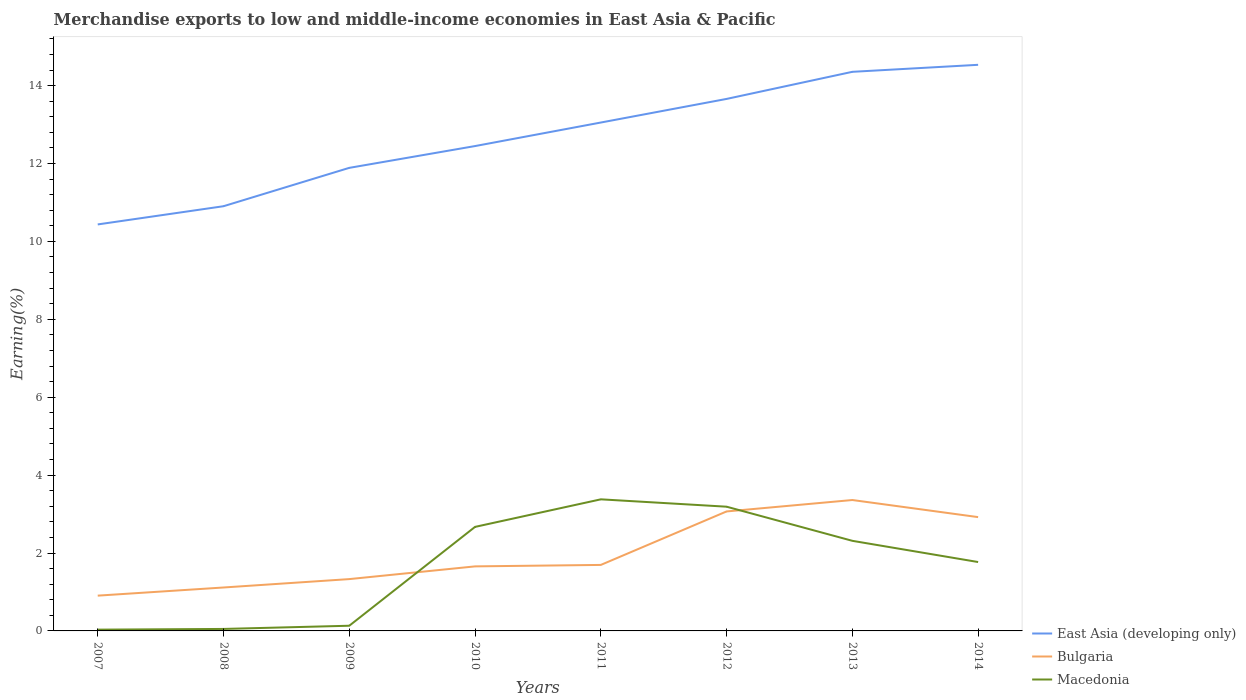Is the number of lines equal to the number of legend labels?
Ensure brevity in your answer.  Yes. Across all years, what is the maximum percentage of amount earned from merchandise exports in East Asia (developing only)?
Your answer should be very brief. 10.44. What is the total percentage of amount earned from merchandise exports in Bulgaria in the graph?
Provide a succinct answer. -0.29. What is the difference between the highest and the second highest percentage of amount earned from merchandise exports in Bulgaria?
Keep it short and to the point. 2.45. What is the difference between the highest and the lowest percentage of amount earned from merchandise exports in Bulgaria?
Your answer should be very brief. 3. Is the percentage of amount earned from merchandise exports in Bulgaria strictly greater than the percentage of amount earned from merchandise exports in East Asia (developing only) over the years?
Ensure brevity in your answer.  Yes. How many lines are there?
Provide a short and direct response. 3. How many years are there in the graph?
Provide a succinct answer. 8. Does the graph contain any zero values?
Provide a short and direct response. No. Where does the legend appear in the graph?
Offer a terse response. Bottom right. How many legend labels are there?
Make the answer very short. 3. What is the title of the graph?
Offer a terse response. Merchandise exports to low and middle-income economies in East Asia & Pacific. Does "Tajikistan" appear as one of the legend labels in the graph?
Offer a very short reply. No. What is the label or title of the Y-axis?
Make the answer very short. Earning(%). What is the Earning(%) of East Asia (developing only) in 2007?
Keep it short and to the point. 10.44. What is the Earning(%) in Bulgaria in 2007?
Make the answer very short. 0.91. What is the Earning(%) in Macedonia in 2007?
Give a very brief answer. 0.03. What is the Earning(%) of East Asia (developing only) in 2008?
Your response must be concise. 10.9. What is the Earning(%) in Bulgaria in 2008?
Offer a very short reply. 1.11. What is the Earning(%) of Macedonia in 2008?
Keep it short and to the point. 0.05. What is the Earning(%) of East Asia (developing only) in 2009?
Offer a very short reply. 11.89. What is the Earning(%) of Bulgaria in 2009?
Offer a very short reply. 1.33. What is the Earning(%) in Macedonia in 2009?
Your answer should be compact. 0.13. What is the Earning(%) of East Asia (developing only) in 2010?
Provide a short and direct response. 12.45. What is the Earning(%) in Bulgaria in 2010?
Provide a succinct answer. 1.66. What is the Earning(%) in Macedonia in 2010?
Give a very brief answer. 2.67. What is the Earning(%) in East Asia (developing only) in 2011?
Your answer should be very brief. 13.05. What is the Earning(%) in Bulgaria in 2011?
Make the answer very short. 1.69. What is the Earning(%) in Macedonia in 2011?
Ensure brevity in your answer.  3.38. What is the Earning(%) of East Asia (developing only) in 2012?
Offer a terse response. 13.66. What is the Earning(%) of Bulgaria in 2012?
Provide a short and direct response. 3.07. What is the Earning(%) of Macedonia in 2012?
Offer a terse response. 3.19. What is the Earning(%) of East Asia (developing only) in 2013?
Offer a very short reply. 14.35. What is the Earning(%) in Bulgaria in 2013?
Offer a terse response. 3.36. What is the Earning(%) of Macedonia in 2013?
Offer a terse response. 2.31. What is the Earning(%) of East Asia (developing only) in 2014?
Your answer should be compact. 14.53. What is the Earning(%) in Bulgaria in 2014?
Provide a succinct answer. 2.92. What is the Earning(%) in Macedonia in 2014?
Your response must be concise. 1.77. Across all years, what is the maximum Earning(%) in East Asia (developing only)?
Ensure brevity in your answer.  14.53. Across all years, what is the maximum Earning(%) of Bulgaria?
Your answer should be very brief. 3.36. Across all years, what is the maximum Earning(%) in Macedonia?
Offer a very short reply. 3.38. Across all years, what is the minimum Earning(%) in East Asia (developing only)?
Your answer should be very brief. 10.44. Across all years, what is the minimum Earning(%) in Bulgaria?
Give a very brief answer. 0.91. Across all years, what is the minimum Earning(%) of Macedonia?
Your response must be concise. 0.03. What is the total Earning(%) of East Asia (developing only) in the graph?
Your response must be concise. 101.27. What is the total Earning(%) in Bulgaria in the graph?
Your answer should be very brief. 16.05. What is the total Earning(%) in Macedonia in the graph?
Provide a short and direct response. 13.54. What is the difference between the Earning(%) in East Asia (developing only) in 2007 and that in 2008?
Provide a short and direct response. -0.47. What is the difference between the Earning(%) in Bulgaria in 2007 and that in 2008?
Give a very brief answer. -0.21. What is the difference between the Earning(%) of Macedonia in 2007 and that in 2008?
Offer a terse response. -0.02. What is the difference between the Earning(%) in East Asia (developing only) in 2007 and that in 2009?
Offer a very short reply. -1.45. What is the difference between the Earning(%) in Bulgaria in 2007 and that in 2009?
Your response must be concise. -0.42. What is the difference between the Earning(%) in Macedonia in 2007 and that in 2009?
Give a very brief answer. -0.1. What is the difference between the Earning(%) in East Asia (developing only) in 2007 and that in 2010?
Your response must be concise. -2.01. What is the difference between the Earning(%) of Bulgaria in 2007 and that in 2010?
Give a very brief answer. -0.75. What is the difference between the Earning(%) of Macedonia in 2007 and that in 2010?
Provide a succinct answer. -2.64. What is the difference between the Earning(%) in East Asia (developing only) in 2007 and that in 2011?
Your answer should be very brief. -2.62. What is the difference between the Earning(%) of Bulgaria in 2007 and that in 2011?
Ensure brevity in your answer.  -0.79. What is the difference between the Earning(%) of Macedonia in 2007 and that in 2011?
Your answer should be compact. -3.35. What is the difference between the Earning(%) in East Asia (developing only) in 2007 and that in 2012?
Provide a succinct answer. -3.22. What is the difference between the Earning(%) of Bulgaria in 2007 and that in 2012?
Make the answer very short. -2.16. What is the difference between the Earning(%) in Macedonia in 2007 and that in 2012?
Make the answer very short. -3.16. What is the difference between the Earning(%) in East Asia (developing only) in 2007 and that in 2013?
Make the answer very short. -3.92. What is the difference between the Earning(%) in Bulgaria in 2007 and that in 2013?
Your response must be concise. -2.45. What is the difference between the Earning(%) in Macedonia in 2007 and that in 2013?
Your answer should be compact. -2.28. What is the difference between the Earning(%) in East Asia (developing only) in 2007 and that in 2014?
Give a very brief answer. -4.1. What is the difference between the Earning(%) in Bulgaria in 2007 and that in 2014?
Ensure brevity in your answer.  -2.02. What is the difference between the Earning(%) of Macedonia in 2007 and that in 2014?
Give a very brief answer. -1.74. What is the difference between the Earning(%) of East Asia (developing only) in 2008 and that in 2009?
Give a very brief answer. -0.98. What is the difference between the Earning(%) in Bulgaria in 2008 and that in 2009?
Your answer should be very brief. -0.22. What is the difference between the Earning(%) in Macedonia in 2008 and that in 2009?
Keep it short and to the point. -0.08. What is the difference between the Earning(%) of East Asia (developing only) in 2008 and that in 2010?
Your answer should be very brief. -1.54. What is the difference between the Earning(%) of Bulgaria in 2008 and that in 2010?
Provide a short and direct response. -0.54. What is the difference between the Earning(%) in Macedonia in 2008 and that in 2010?
Ensure brevity in your answer.  -2.62. What is the difference between the Earning(%) of East Asia (developing only) in 2008 and that in 2011?
Provide a succinct answer. -2.15. What is the difference between the Earning(%) of Bulgaria in 2008 and that in 2011?
Your answer should be compact. -0.58. What is the difference between the Earning(%) of Macedonia in 2008 and that in 2011?
Offer a very short reply. -3.33. What is the difference between the Earning(%) in East Asia (developing only) in 2008 and that in 2012?
Give a very brief answer. -2.75. What is the difference between the Earning(%) of Bulgaria in 2008 and that in 2012?
Your answer should be very brief. -1.95. What is the difference between the Earning(%) of Macedonia in 2008 and that in 2012?
Provide a short and direct response. -3.14. What is the difference between the Earning(%) of East Asia (developing only) in 2008 and that in 2013?
Ensure brevity in your answer.  -3.45. What is the difference between the Earning(%) of Bulgaria in 2008 and that in 2013?
Ensure brevity in your answer.  -2.25. What is the difference between the Earning(%) in Macedonia in 2008 and that in 2013?
Offer a very short reply. -2.26. What is the difference between the Earning(%) of East Asia (developing only) in 2008 and that in 2014?
Your answer should be very brief. -3.63. What is the difference between the Earning(%) in Bulgaria in 2008 and that in 2014?
Make the answer very short. -1.81. What is the difference between the Earning(%) in Macedonia in 2008 and that in 2014?
Ensure brevity in your answer.  -1.72. What is the difference between the Earning(%) in East Asia (developing only) in 2009 and that in 2010?
Your answer should be compact. -0.56. What is the difference between the Earning(%) of Bulgaria in 2009 and that in 2010?
Ensure brevity in your answer.  -0.33. What is the difference between the Earning(%) in Macedonia in 2009 and that in 2010?
Your answer should be compact. -2.54. What is the difference between the Earning(%) of East Asia (developing only) in 2009 and that in 2011?
Provide a short and direct response. -1.16. What is the difference between the Earning(%) in Bulgaria in 2009 and that in 2011?
Keep it short and to the point. -0.36. What is the difference between the Earning(%) of Macedonia in 2009 and that in 2011?
Offer a terse response. -3.25. What is the difference between the Earning(%) in East Asia (developing only) in 2009 and that in 2012?
Keep it short and to the point. -1.77. What is the difference between the Earning(%) of Bulgaria in 2009 and that in 2012?
Keep it short and to the point. -1.74. What is the difference between the Earning(%) in Macedonia in 2009 and that in 2012?
Your response must be concise. -3.06. What is the difference between the Earning(%) in East Asia (developing only) in 2009 and that in 2013?
Make the answer very short. -2.47. What is the difference between the Earning(%) of Bulgaria in 2009 and that in 2013?
Provide a succinct answer. -2.03. What is the difference between the Earning(%) in Macedonia in 2009 and that in 2013?
Ensure brevity in your answer.  -2.18. What is the difference between the Earning(%) in East Asia (developing only) in 2009 and that in 2014?
Provide a short and direct response. -2.65. What is the difference between the Earning(%) of Bulgaria in 2009 and that in 2014?
Give a very brief answer. -1.59. What is the difference between the Earning(%) in Macedonia in 2009 and that in 2014?
Offer a very short reply. -1.64. What is the difference between the Earning(%) in East Asia (developing only) in 2010 and that in 2011?
Provide a succinct answer. -0.6. What is the difference between the Earning(%) of Bulgaria in 2010 and that in 2011?
Keep it short and to the point. -0.04. What is the difference between the Earning(%) of Macedonia in 2010 and that in 2011?
Make the answer very short. -0.71. What is the difference between the Earning(%) of East Asia (developing only) in 2010 and that in 2012?
Keep it short and to the point. -1.21. What is the difference between the Earning(%) in Bulgaria in 2010 and that in 2012?
Your response must be concise. -1.41. What is the difference between the Earning(%) in Macedonia in 2010 and that in 2012?
Ensure brevity in your answer.  -0.52. What is the difference between the Earning(%) in East Asia (developing only) in 2010 and that in 2013?
Your answer should be very brief. -1.91. What is the difference between the Earning(%) in Bulgaria in 2010 and that in 2013?
Provide a succinct answer. -1.7. What is the difference between the Earning(%) of Macedonia in 2010 and that in 2013?
Provide a short and direct response. 0.36. What is the difference between the Earning(%) in East Asia (developing only) in 2010 and that in 2014?
Offer a terse response. -2.09. What is the difference between the Earning(%) of Bulgaria in 2010 and that in 2014?
Your answer should be very brief. -1.26. What is the difference between the Earning(%) of Macedonia in 2010 and that in 2014?
Make the answer very short. 0.9. What is the difference between the Earning(%) of East Asia (developing only) in 2011 and that in 2012?
Make the answer very short. -0.61. What is the difference between the Earning(%) of Bulgaria in 2011 and that in 2012?
Your answer should be compact. -1.37. What is the difference between the Earning(%) of Macedonia in 2011 and that in 2012?
Give a very brief answer. 0.19. What is the difference between the Earning(%) in East Asia (developing only) in 2011 and that in 2013?
Offer a very short reply. -1.3. What is the difference between the Earning(%) of Bulgaria in 2011 and that in 2013?
Give a very brief answer. -1.67. What is the difference between the Earning(%) of Macedonia in 2011 and that in 2013?
Keep it short and to the point. 1.07. What is the difference between the Earning(%) in East Asia (developing only) in 2011 and that in 2014?
Make the answer very short. -1.48. What is the difference between the Earning(%) of Bulgaria in 2011 and that in 2014?
Provide a succinct answer. -1.23. What is the difference between the Earning(%) of Macedonia in 2011 and that in 2014?
Ensure brevity in your answer.  1.61. What is the difference between the Earning(%) of East Asia (developing only) in 2012 and that in 2013?
Give a very brief answer. -0.7. What is the difference between the Earning(%) of Bulgaria in 2012 and that in 2013?
Offer a terse response. -0.29. What is the difference between the Earning(%) in Macedonia in 2012 and that in 2013?
Give a very brief answer. 0.88. What is the difference between the Earning(%) in East Asia (developing only) in 2012 and that in 2014?
Your answer should be compact. -0.88. What is the difference between the Earning(%) in Bulgaria in 2012 and that in 2014?
Provide a short and direct response. 0.15. What is the difference between the Earning(%) in Macedonia in 2012 and that in 2014?
Your answer should be very brief. 1.42. What is the difference between the Earning(%) in East Asia (developing only) in 2013 and that in 2014?
Your response must be concise. -0.18. What is the difference between the Earning(%) of Bulgaria in 2013 and that in 2014?
Your response must be concise. 0.44. What is the difference between the Earning(%) in Macedonia in 2013 and that in 2014?
Offer a terse response. 0.54. What is the difference between the Earning(%) of East Asia (developing only) in 2007 and the Earning(%) of Bulgaria in 2008?
Provide a succinct answer. 9.32. What is the difference between the Earning(%) in East Asia (developing only) in 2007 and the Earning(%) in Macedonia in 2008?
Your response must be concise. 10.39. What is the difference between the Earning(%) in Bulgaria in 2007 and the Earning(%) in Macedonia in 2008?
Ensure brevity in your answer.  0.85. What is the difference between the Earning(%) in East Asia (developing only) in 2007 and the Earning(%) in Bulgaria in 2009?
Offer a very short reply. 9.11. What is the difference between the Earning(%) in East Asia (developing only) in 2007 and the Earning(%) in Macedonia in 2009?
Offer a very short reply. 10.3. What is the difference between the Earning(%) of Bulgaria in 2007 and the Earning(%) of Macedonia in 2009?
Your response must be concise. 0.77. What is the difference between the Earning(%) in East Asia (developing only) in 2007 and the Earning(%) in Bulgaria in 2010?
Offer a terse response. 8.78. What is the difference between the Earning(%) in East Asia (developing only) in 2007 and the Earning(%) in Macedonia in 2010?
Give a very brief answer. 7.77. What is the difference between the Earning(%) of Bulgaria in 2007 and the Earning(%) of Macedonia in 2010?
Provide a succinct answer. -1.76. What is the difference between the Earning(%) in East Asia (developing only) in 2007 and the Earning(%) in Bulgaria in 2011?
Ensure brevity in your answer.  8.74. What is the difference between the Earning(%) of East Asia (developing only) in 2007 and the Earning(%) of Macedonia in 2011?
Your response must be concise. 7.06. What is the difference between the Earning(%) in Bulgaria in 2007 and the Earning(%) in Macedonia in 2011?
Provide a short and direct response. -2.47. What is the difference between the Earning(%) in East Asia (developing only) in 2007 and the Earning(%) in Bulgaria in 2012?
Provide a succinct answer. 7.37. What is the difference between the Earning(%) in East Asia (developing only) in 2007 and the Earning(%) in Macedonia in 2012?
Offer a terse response. 7.25. What is the difference between the Earning(%) of Bulgaria in 2007 and the Earning(%) of Macedonia in 2012?
Provide a succinct answer. -2.28. What is the difference between the Earning(%) of East Asia (developing only) in 2007 and the Earning(%) of Bulgaria in 2013?
Offer a very short reply. 7.08. What is the difference between the Earning(%) of East Asia (developing only) in 2007 and the Earning(%) of Macedonia in 2013?
Your answer should be compact. 8.12. What is the difference between the Earning(%) in Bulgaria in 2007 and the Earning(%) in Macedonia in 2013?
Provide a short and direct response. -1.41. What is the difference between the Earning(%) of East Asia (developing only) in 2007 and the Earning(%) of Bulgaria in 2014?
Keep it short and to the point. 7.51. What is the difference between the Earning(%) in East Asia (developing only) in 2007 and the Earning(%) in Macedonia in 2014?
Your answer should be compact. 8.67. What is the difference between the Earning(%) of Bulgaria in 2007 and the Earning(%) of Macedonia in 2014?
Give a very brief answer. -0.86. What is the difference between the Earning(%) in East Asia (developing only) in 2008 and the Earning(%) in Bulgaria in 2009?
Offer a very short reply. 9.57. What is the difference between the Earning(%) in East Asia (developing only) in 2008 and the Earning(%) in Macedonia in 2009?
Provide a short and direct response. 10.77. What is the difference between the Earning(%) in Bulgaria in 2008 and the Earning(%) in Macedonia in 2009?
Give a very brief answer. 0.98. What is the difference between the Earning(%) in East Asia (developing only) in 2008 and the Earning(%) in Bulgaria in 2010?
Your response must be concise. 9.25. What is the difference between the Earning(%) of East Asia (developing only) in 2008 and the Earning(%) of Macedonia in 2010?
Give a very brief answer. 8.23. What is the difference between the Earning(%) of Bulgaria in 2008 and the Earning(%) of Macedonia in 2010?
Your response must be concise. -1.56. What is the difference between the Earning(%) of East Asia (developing only) in 2008 and the Earning(%) of Bulgaria in 2011?
Offer a terse response. 9.21. What is the difference between the Earning(%) of East Asia (developing only) in 2008 and the Earning(%) of Macedonia in 2011?
Your answer should be compact. 7.53. What is the difference between the Earning(%) of Bulgaria in 2008 and the Earning(%) of Macedonia in 2011?
Keep it short and to the point. -2.26. What is the difference between the Earning(%) in East Asia (developing only) in 2008 and the Earning(%) in Bulgaria in 2012?
Keep it short and to the point. 7.84. What is the difference between the Earning(%) in East Asia (developing only) in 2008 and the Earning(%) in Macedonia in 2012?
Provide a succinct answer. 7.71. What is the difference between the Earning(%) in Bulgaria in 2008 and the Earning(%) in Macedonia in 2012?
Your response must be concise. -2.07. What is the difference between the Earning(%) of East Asia (developing only) in 2008 and the Earning(%) of Bulgaria in 2013?
Provide a succinct answer. 7.54. What is the difference between the Earning(%) of East Asia (developing only) in 2008 and the Earning(%) of Macedonia in 2013?
Keep it short and to the point. 8.59. What is the difference between the Earning(%) in Bulgaria in 2008 and the Earning(%) in Macedonia in 2013?
Provide a short and direct response. -1.2. What is the difference between the Earning(%) of East Asia (developing only) in 2008 and the Earning(%) of Bulgaria in 2014?
Your response must be concise. 7.98. What is the difference between the Earning(%) in East Asia (developing only) in 2008 and the Earning(%) in Macedonia in 2014?
Your response must be concise. 9.13. What is the difference between the Earning(%) of Bulgaria in 2008 and the Earning(%) of Macedonia in 2014?
Offer a terse response. -0.65. What is the difference between the Earning(%) in East Asia (developing only) in 2009 and the Earning(%) in Bulgaria in 2010?
Offer a very short reply. 10.23. What is the difference between the Earning(%) of East Asia (developing only) in 2009 and the Earning(%) of Macedonia in 2010?
Provide a succinct answer. 9.22. What is the difference between the Earning(%) in Bulgaria in 2009 and the Earning(%) in Macedonia in 2010?
Offer a terse response. -1.34. What is the difference between the Earning(%) of East Asia (developing only) in 2009 and the Earning(%) of Bulgaria in 2011?
Offer a terse response. 10.19. What is the difference between the Earning(%) of East Asia (developing only) in 2009 and the Earning(%) of Macedonia in 2011?
Offer a terse response. 8.51. What is the difference between the Earning(%) of Bulgaria in 2009 and the Earning(%) of Macedonia in 2011?
Your response must be concise. -2.05. What is the difference between the Earning(%) in East Asia (developing only) in 2009 and the Earning(%) in Bulgaria in 2012?
Offer a very short reply. 8.82. What is the difference between the Earning(%) of East Asia (developing only) in 2009 and the Earning(%) of Macedonia in 2012?
Your answer should be very brief. 8.7. What is the difference between the Earning(%) in Bulgaria in 2009 and the Earning(%) in Macedonia in 2012?
Provide a succinct answer. -1.86. What is the difference between the Earning(%) of East Asia (developing only) in 2009 and the Earning(%) of Bulgaria in 2013?
Your answer should be very brief. 8.53. What is the difference between the Earning(%) of East Asia (developing only) in 2009 and the Earning(%) of Macedonia in 2013?
Offer a terse response. 9.58. What is the difference between the Earning(%) of Bulgaria in 2009 and the Earning(%) of Macedonia in 2013?
Make the answer very short. -0.98. What is the difference between the Earning(%) in East Asia (developing only) in 2009 and the Earning(%) in Bulgaria in 2014?
Your response must be concise. 8.97. What is the difference between the Earning(%) of East Asia (developing only) in 2009 and the Earning(%) of Macedonia in 2014?
Offer a very short reply. 10.12. What is the difference between the Earning(%) of Bulgaria in 2009 and the Earning(%) of Macedonia in 2014?
Offer a very short reply. -0.44. What is the difference between the Earning(%) of East Asia (developing only) in 2010 and the Earning(%) of Bulgaria in 2011?
Your answer should be compact. 10.75. What is the difference between the Earning(%) of East Asia (developing only) in 2010 and the Earning(%) of Macedonia in 2011?
Offer a terse response. 9.07. What is the difference between the Earning(%) of Bulgaria in 2010 and the Earning(%) of Macedonia in 2011?
Offer a very short reply. -1.72. What is the difference between the Earning(%) in East Asia (developing only) in 2010 and the Earning(%) in Bulgaria in 2012?
Offer a very short reply. 9.38. What is the difference between the Earning(%) in East Asia (developing only) in 2010 and the Earning(%) in Macedonia in 2012?
Provide a succinct answer. 9.26. What is the difference between the Earning(%) in Bulgaria in 2010 and the Earning(%) in Macedonia in 2012?
Ensure brevity in your answer.  -1.53. What is the difference between the Earning(%) in East Asia (developing only) in 2010 and the Earning(%) in Bulgaria in 2013?
Provide a succinct answer. 9.09. What is the difference between the Earning(%) of East Asia (developing only) in 2010 and the Earning(%) of Macedonia in 2013?
Ensure brevity in your answer.  10.13. What is the difference between the Earning(%) of Bulgaria in 2010 and the Earning(%) of Macedonia in 2013?
Give a very brief answer. -0.66. What is the difference between the Earning(%) of East Asia (developing only) in 2010 and the Earning(%) of Bulgaria in 2014?
Keep it short and to the point. 9.53. What is the difference between the Earning(%) in East Asia (developing only) in 2010 and the Earning(%) in Macedonia in 2014?
Your answer should be very brief. 10.68. What is the difference between the Earning(%) in Bulgaria in 2010 and the Earning(%) in Macedonia in 2014?
Ensure brevity in your answer.  -0.11. What is the difference between the Earning(%) in East Asia (developing only) in 2011 and the Earning(%) in Bulgaria in 2012?
Keep it short and to the point. 9.98. What is the difference between the Earning(%) in East Asia (developing only) in 2011 and the Earning(%) in Macedonia in 2012?
Your answer should be very brief. 9.86. What is the difference between the Earning(%) of Bulgaria in 2011 and the Earning(%) of Macedonia in 2012?
Your answer should be compact. -1.49. What is the difference between the Earning(%) in East Asia (developing only) in 2011 and the Earning(%) in Bulgaria in 2013?
Provide a succinct answer. 9.69. What is the difference between the Earning(%) in East Asia (developing only) in 2011 and the Earning(%) in Macedonia in 2013?
Make the answer very short. 10.74. What is the difference between the Earning(%) of Bulgaria in 2011 and the Earning(%) of Macedonia in 2013?
Make the answer very short. -0.62. What is the difference between the Earning(%) of East Asia (developing only) in 2011 and the Earning(%) of Bulgaria in 2014?
Keep it short and to the point. 10.13. What is the difference between the Earning(%) in East Asia (developing only) in 2011 and the Earning(%) in Macedonia in 2014?
Your answer should be very brief. 11.28. What is the difference between the Earning(%) in Bulgaria in 2011 and the Earning(%) in Macedonia in 2014?
Provide a short and direct response. -0.07. What is the difference between the Earning(%) of East Asia (developing only) in 2012 and the Earning(%) of Bulgaria in 2013?
Offer a very short reply. 10.3. What is the difference between the Earning(%) of East Asia (developing only) in 2012 and the Earning(%) of Macedonia in 2013?
Offer a very short reply. 11.34. What is the difference between the Earning(%) of Bulgaria in 2012 and the Earning(%) of Macedonia in 2013?
Provide a succinct answer. 0.75. What is the difference between the Earning(%) of East Asia (developing only) in 2012 and the Earning(%) of Bulgaria in 2014?
Provide a succinct answer. 10.74. What is the difference between the Earning(%) of East Asia (developing only) in 2012 and the Earning(%) of Macedonia in 2014?
Your response must be concise. 11.89. What is the difference between the Earning(%) in Bulgaria in 2012 and the Earning(%) in Macedonia in 2014?
Your answer should be compact. 1.3. What is the difference between the Earning(%) in East Asia (developing only) in 2013 and the Earning(%) in Bulgaria in 2014?
Offer a very short reply. 11.43. What is the difference between the Earning(%) in East Asia (developing only) in 2013 and the Earning(%) in Macedonia in 2014?
Provide a succinct answer. 12.59. What is the difference between the Earning(%) in Bulgaria in 2013 and the Earning(%) in Macedonia in 2014?
Ensure brevity in your answer.  1.59. What is the average Earning(%) of East Asia (developing only) per year?
Keep it short and to the point. 12.66. What is the average Earning(%) in Bulgaria per year?
Ensure brevity in your answer.  2.01. What is the average Earning(%) in Macedonia per year?
Keep it short and to the point. 1.69. In the year 2007, what is the difference between the Earning(%) of East Asia (developing only) and Earning(%) of Bulgaria?
Your answer should be very brief. 9.53. In the year 2007, what is the difference between the Earning(%) of East Asia (developing only) and Earning(%) of Macedonia?
Your answer should be very brief. 10.4. In the year 2007, what is the difference between the Earning(%) of Bulgaria and Earning(%) of Macedonia?
Your answer should be very brief. 0.87. In the year 2008, what is the difference between the Earning(%) in East Asia (developing only) and Earning(%) in Bulgaria?
Make the answer very short. 9.79. In the year 2008, what is the difference between the Earning(%) of East Asia (developing only) and Earning(%) of Macedonia?
Your answer should be very brief. 10.85. In the year 2008, what is the difference between the Earning(%) of Bulgaria and Earning(%) of Macedonia?
Ensure brevity in your answer.  1.06. In the year 2009, what is the difference between the Earning(%) in East Asia (developing only) and Earning(%) in Bulgaria?
Make the answer very short. 10.56. In the year 2009, what is the difference between the Earning(%) of East Asia (developing only) and Earning(%) of Macedonia?
Offer a terse response. 11.76. In the year 2009, what is the difference between the Earning(%) of Bulgaria and Earning(%) of Macedonia?
Provide a short and direct response. 1.2. In the year 2010, what is the difference between the Earning(%) of East Asia (developing only) and Earning(%) of Bulgaria?
Provide a short and direct response. 10.79. In the year 2010, what is the difference between the Earning(%) in East Asia (developing only) and Earning(%) in Macedonia?
Offer a very short reply. 9.78. In the year 2010, what is the difference between the Earning(%) of Bulgaria and Earning(%) of Macedonia?
Offer a terse response. -1.01. In the year 2011, what is the difference between the Earning(%) of East Asia (developing only) and Earning(%) of Bulgaria?
Keep it short and to the point. 11.36. In the year 2011, what is the difference between the Earning(%) in East Asia (developing only) and Earning(%) in Macedonia?
Ensure brevity in your answer.  9.67. In the year 2011, what is the difference between the Earning(%) of Bulgaria and Earning(%) of Macedonia?
Ensure brevity in your answer.  -1.68. In the year 2012, what is the difference between the Earning(%) of East Asia (developing only) and Earning(%) of Bulgaria?
Offer a terse response. 10.59. In the year 2012, what is the difference between the Earning(%) in East Asia (developing only) and Earning(%) in Macedonia?
Your response must be concise. 10.47. In the year 2012, what is the difference between the Earning(%) of Bulgaria and Earning(%) of Macedonia?
Your answer should be very brief. -0.12. In the year 2013, what is the difference between the Earning(%) of East Asia (developing only) and Earning(%) of Bulgaria?
Make the answer very short. 10.99. In the year 2013, what is the difference between the Earning(%) of East Asia (developing only) and Earning(%) of Macedonia?
Keep it short and to the point. 12.04. In the year 2013, what is the difference between the Earning(%) in Bulgaria and Earning(%) in Macedonia?
Keep it short and to the point. 1.05. In the year 2014, what is the difference between the Earning(%) in East Asia (developing only) and Earning(%) in Bulgaria?
Make the answer very short. 11.61. In the year 2014, what is the difference between the Earning(%) of East Asia (developing only) and Earning(%) of Macedonia?
Your answer should be very brief. 12.77. In the year 2014, what is the difference between the Earning(%) in Bulgaria and Earning(%) in Macedonia?
Make the answer very short. 1.15. What is the ratio of the Earning(%) of East Asia (developing only) in 2007 to that in 2008?
Your answer should be compact. 0.96. What is the ratio of the Earning(%) in Bulgaria in 2007 to that in 2008?
Offer a very short reply. 0.81. What is the ratio of the Earning(%) in Macedonia in 2007 to that in 2008?
Give a very brief answer. 0.64. What is the ratio of the Earning(%) of East Asia (developing only) in 2007 to that in 2009?
Offer a very short reply. 0.88. What is the ratio of the Earning(%) in Bulgaria in 2007 to that in 2009?
Your response must be concise. 0.68. What is the ratio of the Earning(%) in Macedonia in 2007 to that in 2009?
Offer a terse response. 0.25. What is the ratio of the Earning(%) in East Asia (developing only) in 2007 to that in 2010?
Your answer should be very brief. 0.84. What is the ratio of the Earning(%) of Bulgaria in 2007 to that in 2010?
Provide a succinct answer. 0.55. What is the ratio of the Earning(%) of Macedonia in 2007 to that in 2010?
Make the answer very short. 0.01. What is the ratio of the Earning(%) of East Asia (developing only) in 2007 to that in 2011?
Your response must be concise. 0.8. What is the ratio of the Earning(%) in Bulgaria in 2007 to that in 2011?
Your answer should be very brief. 0.53. What is the ratio of the Earning(%) of Macedonia in 2007 to that in 2011?
Ensure brevity in your answer.  0.01. What is the ratio of the Earning(%) in East Asia (developing only) in 2007 to that in 2012?
Give a very brief answer. 0.76. What is the ratio of the Earning(%) in Bulgaria in 2007 to that in 2012?
Your answer should be very brief. 0.3. What is the ratio of the Earning(%) in Macedonia in 2007 to that in 2012?
Ensure brevity in your answer.  0.01. What is the ratio of the Earning(%) in East Asia (developing only) in 2007 to that in 2013?
Your answer should be very brief. 0.73. What is the ratio of the Earning(%) of Bulgaria in 2007 to that in 2013?
Give a very brief answer. 0.27. What is the ratio of the Earning(%) of Macedonia in 2007 to that in 2013?
Your answer should be compact. 0.01. What is the ratio of the Earning(%) in East Asia (developing only) in 2007 to that in 2014?
Provide a succinct answer. 0.72. What is the ratio of the Earning(%) of Bulgaria in 2007 to that in 2014?
Your response must be concise. 0.31. What is the ratio of the Earning(%) of Macedonia in 2007 to that in 2014?
Give a very brief answer. 0.02. What is the ratio of the Earning(%) of East Asia (developing only) in 2008 to that in 2009?
Provide a succinct answer. 0.92. What is the ratio of the Earning(%) in Bulgaria in 2008 to that in 2009?
Keep it short and to the point. 0.84. What is the ratio of the Earning(%) in Macedonia in 2008 to that in 2009?
Offer a terse response. 0.38. What is the ratio of the Earning(%) of East Asia (developing only) in 2008 to that in 2010?
Offer a terse response. 0.88. What is the ratio of the Earning(%) in Bulgaria in 2008 to that in 2010?
Offer a terse response. 0.67. What is the ratio of the Earning(%) of Macedonia in 2008 to that in 2010?
Provide a short and direct response. 0.02. What is the ratio of the Earning(%) of East Asia (developing only) in 2008 to that in 2011?
Provide a short and direct response. 0.84. What is the ratio of the Earning(%) of Bulgaria in 2008 to that in 2011?
Keep it short and to the point. 0.66. What is the ratio of the Earning(%) of Macedonia in 2008 to that in 2011?
Your answer should be compact. 0.02. What is the ratio of the Earning(%) in East Asia (developing only) in 2008 to that in 2012?
Your answer should be compact. 0.8. What is the ratio of the Earning(%) in Bulgaria in 2008 to that in 2012?
Ensure brevity in your answer.  0.36. What is the ratio of the Earning(%) in Macedonia in 2008 to that in 2012?
Offer a very short reply. 0.02. What is the ratio of the Earning(%) of East Asia (developing only) in 2008 to that in 2013?
Your answer should be very brief. 0.76. What is the ratio of the Earning(%) of Bulgaria in 2008 to that in 2013?
Offer a very short reply. 0.33. What is the ratio of the Earning(%) of Macedonia in 2008 to that in 2013?
Offer a very short reply. 0.02. What is the ratio of the Earning(%) of East Asia (developing only) in 2008 to that in 2014?
Make the answer very short. 0.75. What is the ratio of the Earning(%) in Bulgaria in 2008 to that in 2014?
Give a very brief answer. 0.38. What is the ratio of the Earning(%) in Macedonia in 2008 to that in 2014?
Keep it short and to the point. 0.03. What is the ratio of the Earning(%) in East Asia (developing only) in 2009 to that in 2010?
Your answer should be compact. 0.95. What is the ratio of the Earning(%) in Bulgaria in 2009 to that in 2010?
Offer a terse response. 0.8. What is the ratio of the Earning(%) of Macedonia in 2009 to that in 2010?
Offer a very short reply. 0.05. What is the ratio of the Earning(%) of East Asia (developing only) in 2009 to that in 2011?
Ensure brevity in your answer.  0.91. What is the ratio of the Earning(%) in Bulgaria in 2009 to that in 2011?
Provide a short and direct response. 0.79. What is the ratio of the Earning(%) of Macedonia in 2009 to that in 2011?
Ensure brevity in your answer.  0.04. What is the ratio of the Earning(%) of East Asia (developing only) in 2009 to that in 2012?
Offer a terse response. 0.87. What is the ratio of the Earning(%) in Bulgaria in 2009 to that in 2012?
Provide a short and direct response. 0.43. What is the ratio of the Earning(%) in Macedonia in 2009 to that in 2012?
Provide a succinct answer. 0.04. What is the ratio of the Earning(%) of East Asia (developing only) in 2009 to that in 2013?
Offer a very short reply. 0.83. What is the ratio of the Earning(%) in Bulgaria in 2009 to that in 2013?
Provide a short and direct response. 0.4. What is the ratio of the Earning(%) in Macedonia in 2009 to that in 2013?
Give a very brief answer. 0.06. What is the ratio of the Earning(%) in East Asia (developing only) in 2009 to that in 2014?
Offer a terse response. 0.82. What is the ratio of the Earning(%) of Bulgaria in 2009 to that in 2014?
Your answer should be compact. 0.46. What is the ratio of the Earning(%) in Macedonia in 2009 to that in 2014?
Make the answer very short. 0.08. What is the ratio of the Earning(%) of East Asia (developing only) in 2010 to that in 2011?
Provide a succinct answer. 0.95. What is the ratio of the Earning(%) in Bulgaria in 2010 to that in 2011?
Offer a very short reply. 0.98. What is the ratio of the Earning(%) of Macedonia in 2010 to that in 2011?
Your answer should be very brief. 0.79. What is the ratio of the Earning(%) in East Asia (developing only) in 2010 to that in 2012?
Your answer should be compact. 0.91. What is the ratio of the Earning(%) of Bulgaria in 2010 to that in 2012?
Your answer should be very brief. 0.54. What is the ratio of the Earning(%) of Macedonia in 2010 to that in 2012?
Provide a short and direct response. 0.84. What is the ratio of the Earning(%) in East Asia (developing only) in 2010 to that in 2013?
Ensure brevity in your answer.  0.87. What is the ratio of the Earning(%) of Bulgaria in 2010 to that in 2013?
Your answer should be compact. 0.49. What is the ratio of the Earning(%) of Macedonia in 2010 to that in 2013?
Offer a terse response. 1.15. What is the ratio of the Earning(%) in East Asia (developing only) in 2010 to that in 2014?
Make the answer very short. 0.86. What is the ratio of the Earning(%) of Bulgaria in 2010 to that in 2014?
Your answer should be very brief. 0.57. What is the ratio of the Earning(%) in Macedonia in 2010 to that in 2014?
Your answer should be very brief. 1.51. What is the ratio of the Earning(%) in East Asia (developing only) in 2011 to that in 2012?
Ensure brevity in your answer.  0.96. What is the ratio of the Earning(%) in Bulgaria in 2011 to that in 2012?
Provide a short and direct response. 0.55. What is the ratio of the Earning(%) in Macedonia in 2011 to that in 2012?
Your answer should be very brief. 1.06. What is the ratio of the Earning(%) of East Asia (developing only) in 2011 to that in 2013?
Offer a terse response. 0.91. What is the ratio of the Earning(%) of Bulgaria in 2011 to that in 2013?
Make the answer very short. 0.5. What is the ratio of the Earning(%) in Macedonia in 2011 to that in 2013?
Your answer should be compact. 1.46. What is the ratio of the Earning(%) of East Asia (developing only) in 2011 to that in 2014?
Your response must be concise. 0.9. What is the ratio of the Earning(%) of Bulgaria in 2011 to that in 2014?
Give a very brief answer. 0.58. What is the ratio of the Earning(%) of Macedonia in 2011 to that in 2014?
Give a very brief answer. 1.91. What is the ratio of the Earning(%) of East Asia (developing only) in 2012 to that in 2013?
Offer a terse response. 0.95. What is the ratio of the Earning(%) in Bulgaria in 2012 to that in 2013?
Provide a succinct answer. 0.91. What is the ratio of the Earning(%) of Macedonia in 2012 to that in 2013?
Make the answer very short. 1.38. What is the ratio of the Earning(%) of East Asia (developing only) in 2012 to that in 2014?
Ensure brevity in your answer.  0.94. What is the ratio of the Earning(%) in Bulgaria in 2012 to that in 2014?
Provide a short and direct response. 1.05. What is the ratio of the Earning(%) of Macedonia in 2012 to that in 2014?
Your answer should be very brief. 1.8. What is the ratio of the Earning(%) of East Asia (developing only) in 2013 to that in 2014?
Your answer should be compact. 0.99. What is the ratio of the Earning(%) of Bulgaria in 2013 to that in 2014?
Give a very brief answer. 1.15. What is the ratio of the Earning(%) in Macedonia in 2013 to that in 2014?
Give a very brief answer. 1.31. What is the difference between the highest and the second highest Earning(%) of East Asia (developing only)?
Your answer should be very brief. 0.18. What is the difference between the highest and the second highest Earning(%) of Bulgaria?
Your answer should be very brief. 0.29. What is the difference between the highest and the second highest Earning(%) in Macedonia?
Keep it short and to the point. 0.19. What is the difference between the highest and the lowest Earning(%) in East Asia (developing only)?
Give a very brief answer. 4.1. What is the difference between the highest and the lowest Earning(%) of Bulgaria?
Offer a very short reply. 2.45. What is the difference between the highest and the lowest Earning(%) in Macedonia?
Your response must be concise. 3.35. 